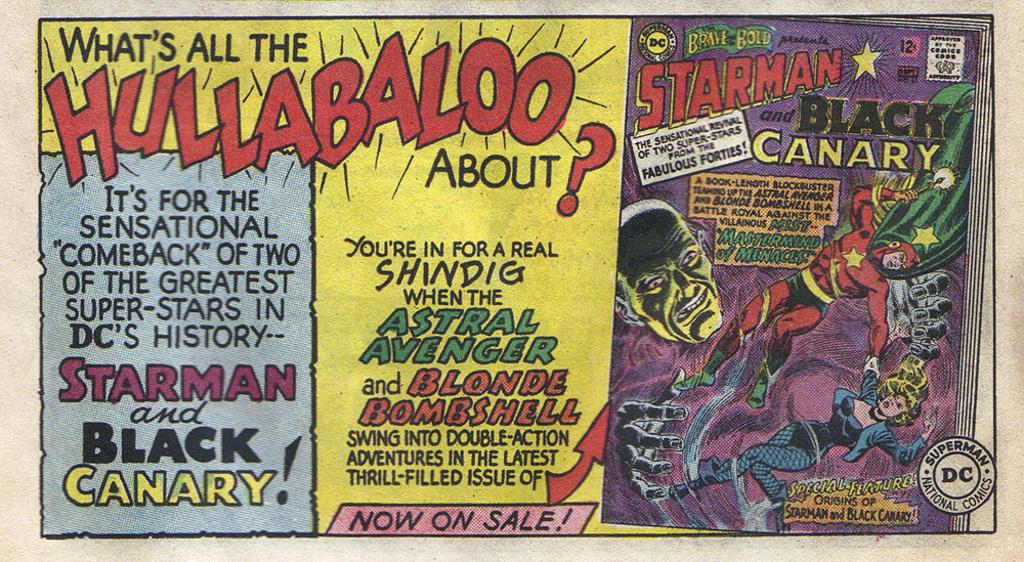Who is with starman?
Your response must be concise. Black canary. 